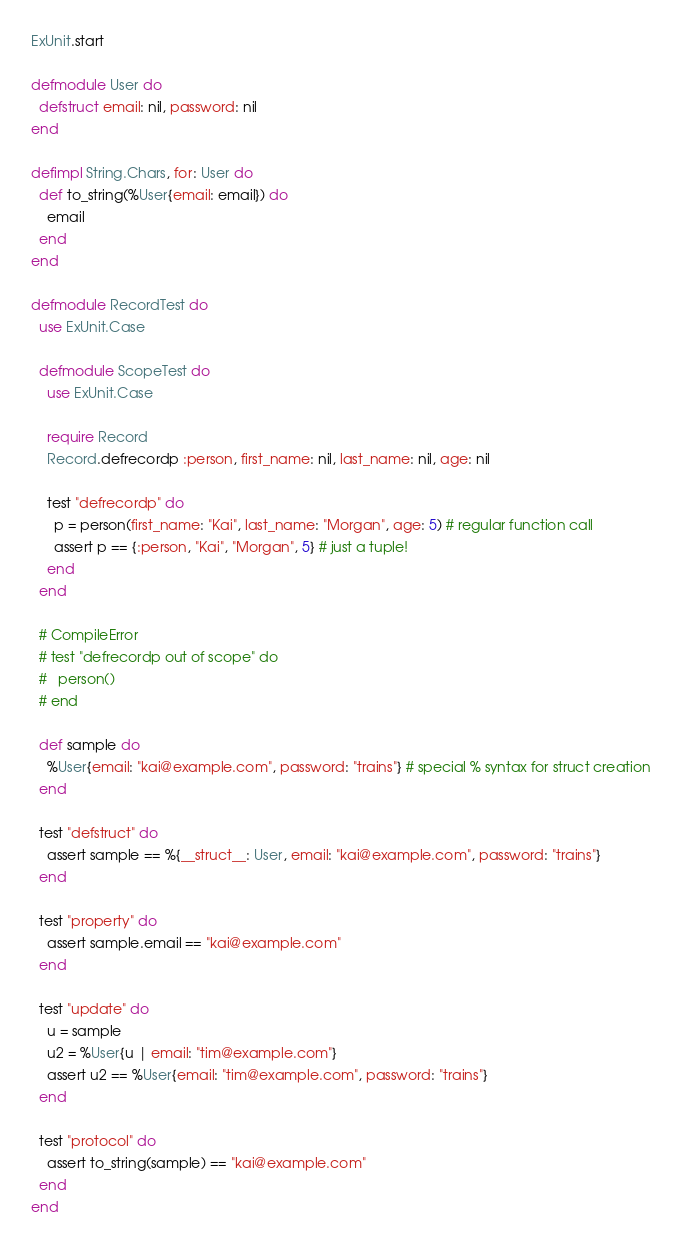<code> <loc_0><loc_0><loc_500><loc_500><_Elixir_>ExUnit.start

defmodule User do
  defstruct email: nil, password: nil
end

defimpl String.Chars, for: User do
  def to_string(%User{email: email}) do
    email
  end
end

defmodule RecordTest do
  use ExUnit.Case

  defmodule ScopeTest do
    use ExUnit.Case

    require Record
    Record.defrecordp :person, first_name: nil, last_name: nil, age: nil

    test "defrecordp" do
      p = person(first_name: "Kai", last_name: "Morgan", age: 5) # regular function call
      assert p == {:person, "Kai", "Morgan", 5} # just a tuple!
    end
  end

  # CompileError
  # test "defrecordp out of scope" do
  #   person()
  # end

  def sample do
    %User{email: "kai@example.com", password: "trains"} # special % syntax for struct creation
  end

  test "defstruct" do
    assert sample == %{__struct__: User, email: "kai@example.com", password: "trains"}
  end

  test "property" do
    assert sample.email == "kai@example.com"
  end

  test "update" do
    u = sample
    u2 = %User{u | email: "tim@example.com"}
    assert u2 == %User{email: "tim@example.com", password: "trains"}
  end

  test "protocol" do
    assert to_string(sample) == "kai@example.com"
  end
end

</code> 